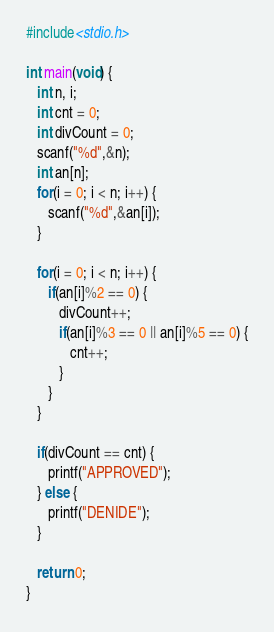<code> <loc_0><loc_0><loc_500><loc_500><_C_>#include<stdio.h>

int main(void) {
   int n, i;
   int cnt = 0;
   int divCount = 0;
   scanf("%d",&n);
   int an[n];
   for(i = 0; i < n; i++) {
      scanf("%d",&an[i]);
   }

   for(i = 0; i < n; i++) {
      if(an[i]%2 == 0) {
         divCount++;
         if(an[i]%3 == 0 || an[i]%5 == 0) {
            cnt++;
         }
      }
   }

   if(divCount == cnt) {
      printf("APPROVED");
   } else {
      printf("DENIDE");
   }

   return 0;
}
</code> 